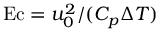<formula> <loc_0><loc_0><loc_500><loc_500>E c = u _ { 0 } ^ { 2 } / ( C _ { p } \Delta T )</formula> 